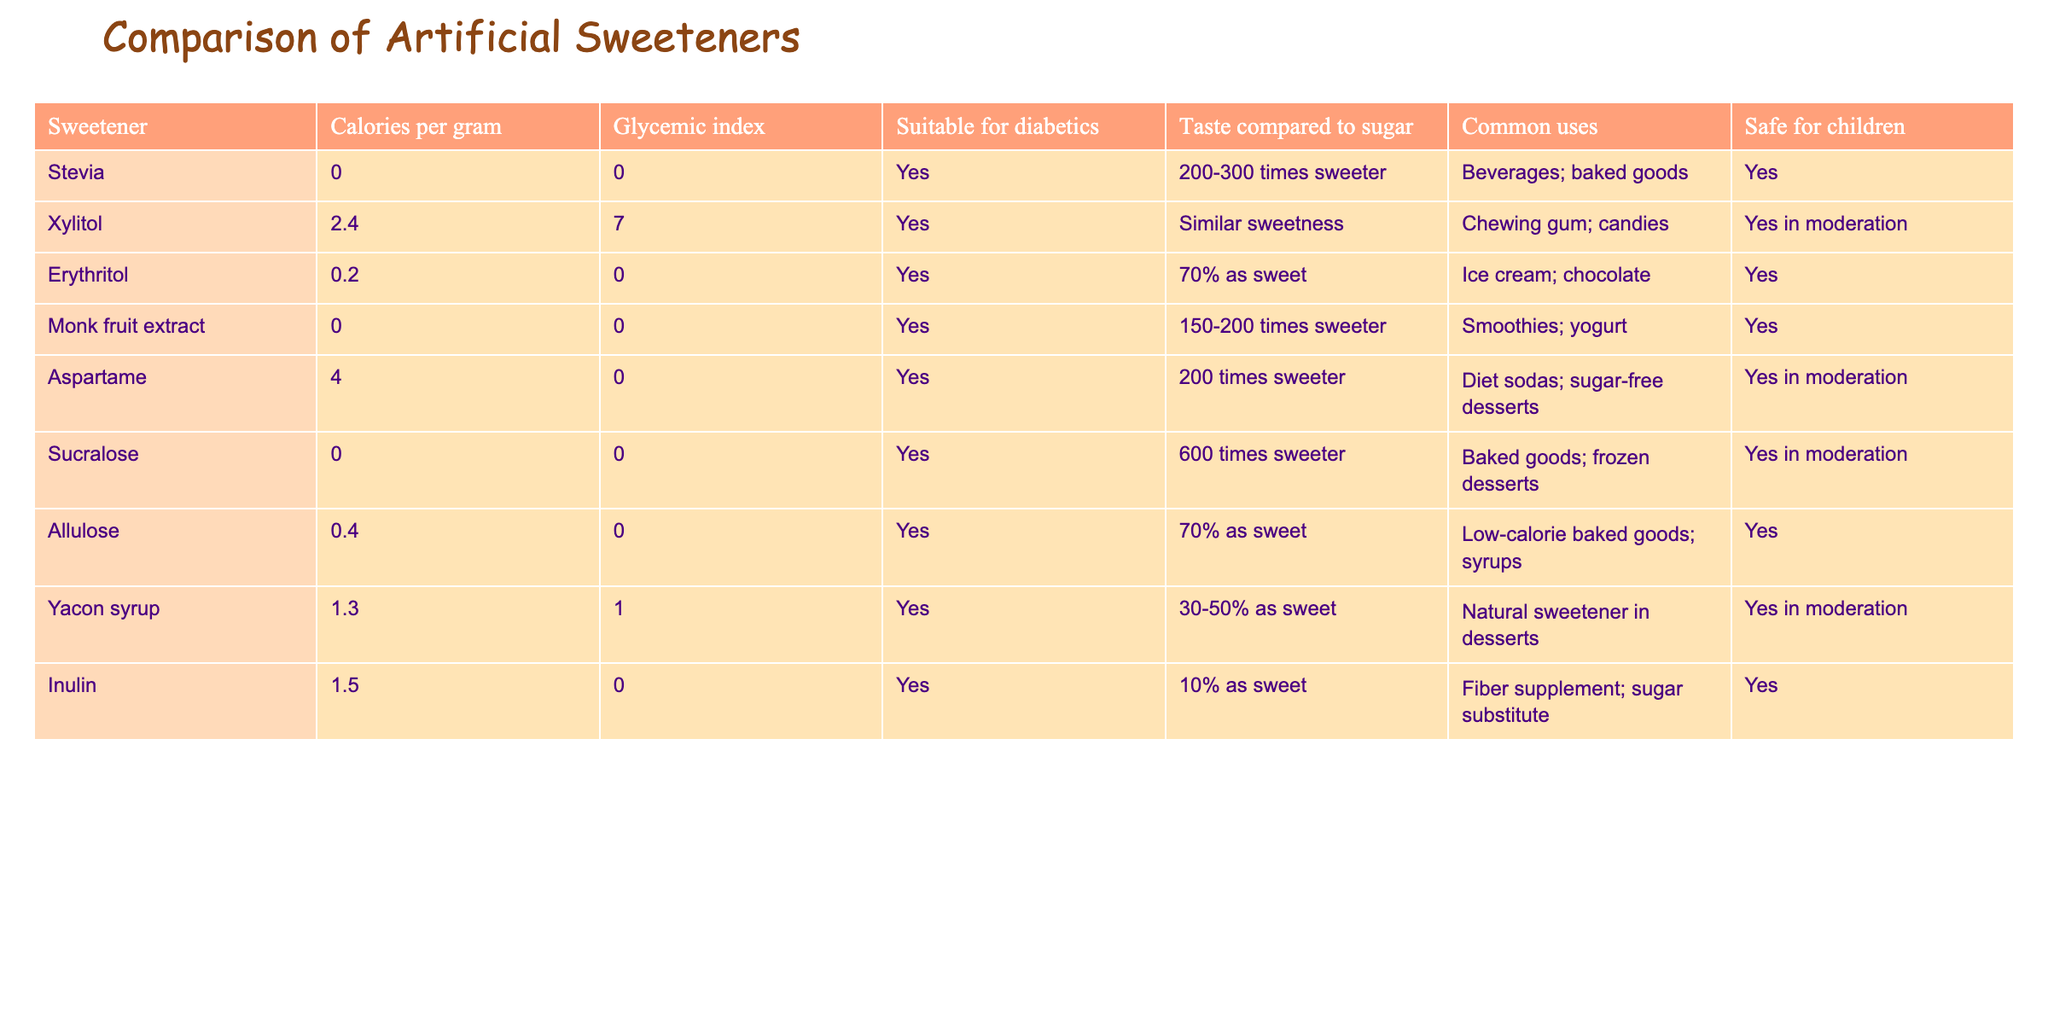What is the glycemic index of erythritol? The glycemic index of erythritol is listed in the table, and it shows 0.
Answer: 0 Which sweetener has the highest calories per gram? By observing the calories per gram column, xylitol has the highest value at 2.4.
Answer: 2.4 Are all the sweeteners suitable for diabetics? The table indicates that all sweeteners have "Yes" under the suitable for diabetics column, confirming that they are all suitable.
Answer: Yes What is the average glycemic index of the sweeteners listed? The glycemic index values are 0, 7, 0, 0, 0, 0, 0, 1, and 0. The sum is 8, and there are 9 sweeteners, so the average is 8/9 = 0.89.
Answer: 0.89 How many sweeteners are safe for children? By checking the safe for children column, we see that all sweeteners except xylitol and aspartame (marked as "Yes in moderation") are safe, making a total of 9.
Answer: 9 Which sweetener is 600 times sweeter than sugar? Looking at the taste compared to sugar column, it shows that sucralose is 600 times sweeter.
Answer: Sucralose What is the difference in calories between xylitol and erythritol? The calories for xylitol is 2.4 and for erythritol is 0.2. The difference is calculated as 2.4 - 0.2 = 2.2.
Answer: 2.2 Is monk fruit extract safe for children? According to the table, monk fruit extract has "Yes" listed under the safe for children column.
Answer: Yes What common use is shared by erythritol and xylitol? Looking at the common uses in the table, both erythritol and xylitol are commonly used in "candies," and both also have desserts listed, showing a shared use.
Answer: Chewing gum; candies 